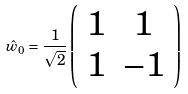<formula> <loc_0><loc_0><loc_500><loc_500>\hat { w } _ { 0 } = \frac { 1 } { \sqrt { 2 } } \left ( \begin{array} { c c } 1 & 1 \\ 1 & - 1 \end{array} \right )</formula> 